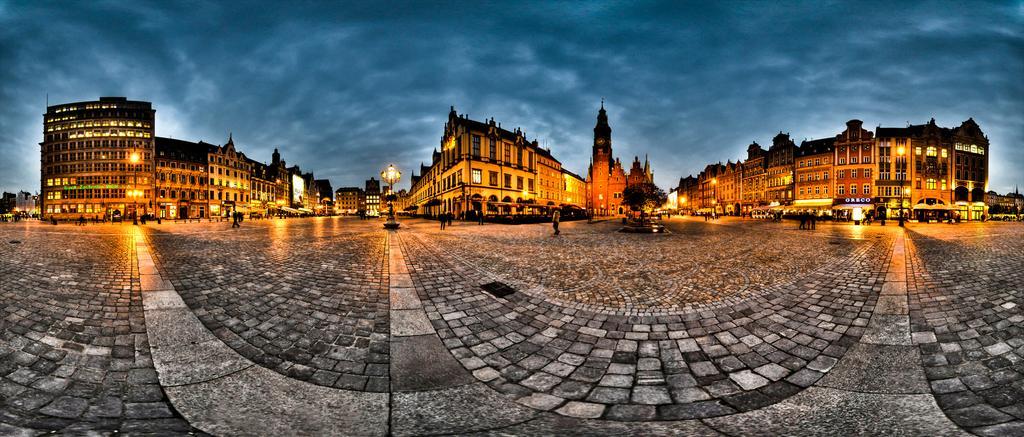Please provide a concise description of this image. In this image we can see buildings with windows. Also there are lights. And there are trees. In the background there is sky with clouds. Also we can see many people. 